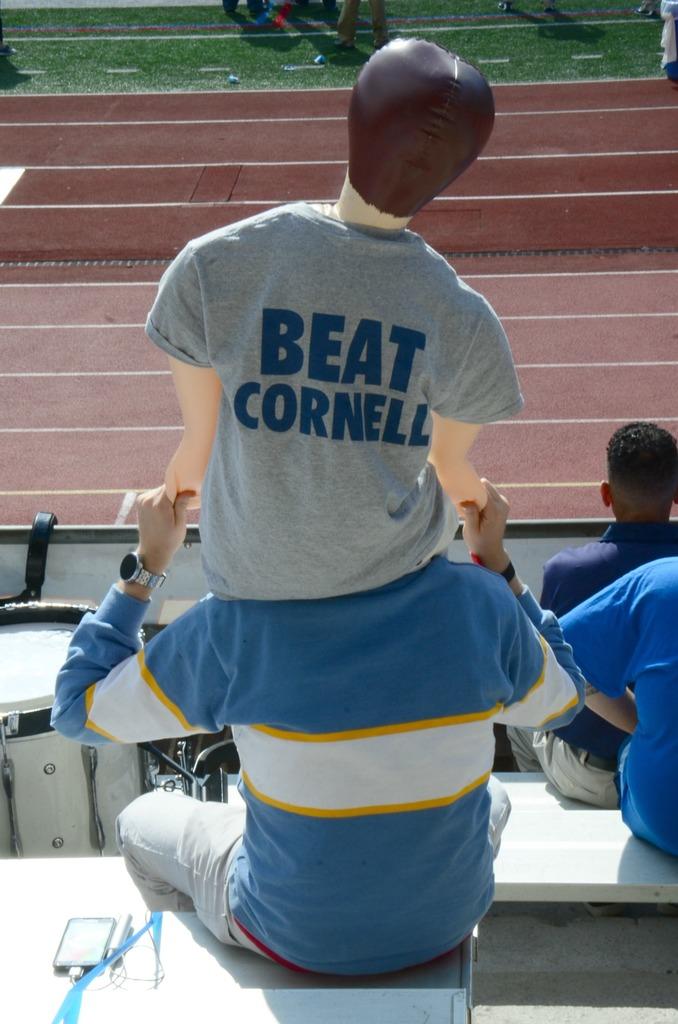What does the shirt say?
Your answer should be compact. Beat cornell. 